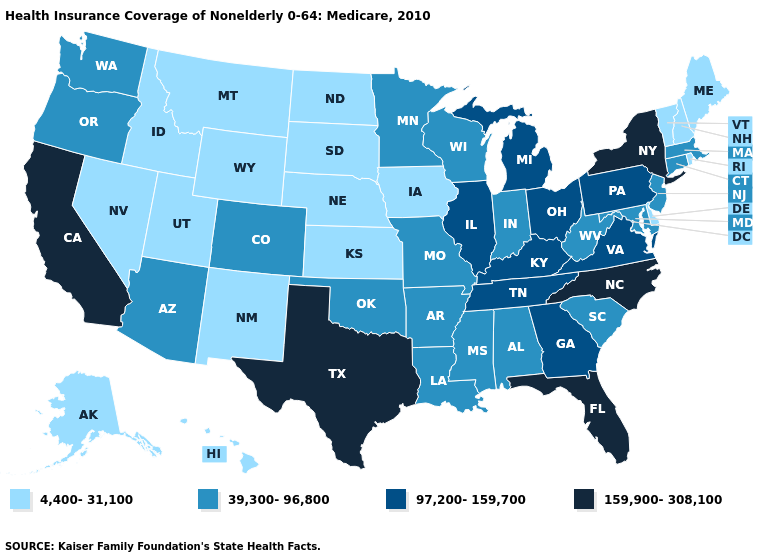Does West Virginia have the lowest value in the USA?
Concise answer only. No. Name the states that have a value in the range 4,400-31,100?
Quick response, please. Alaska, Delaware, Hawaii, Idaho, Iowa, Kansas, Maine, Montana, Nebraska, Nevada, New Hampshire, New Mexico, North Dakota, Rhode Island, South Dakota, Utah, Vermont, Wyoming. What is the lowest value in the West?
Answer briefly. 4,400-31,100. How many symbols are there in the legend?
Be succinct. 4. Name the states that have a value in the range 97,200-159,700?
Short answer required. Georgia, Illinois, Kentucky, Michigan, Ohio, Pennsylvania, Tennessee, Virginia. What is the value of Michigan?
Be succinct. 97,200-159,700. What is the highest value in the West ?
Short answer required. 159,900-308,100. What is the value of Louisiana?
Be succinct. 39,300-96,800. Which states hav the highest value in the West?
Concise answer only. California. What is the lowest value in states that border Nebraska?
Quick response, please. 4,400-31,100. What is the value of South Carolina?
Quick response, please. 39,300-96,800. Does Delaware have the lowest value in the South?
Be succinct. Yes. Does Florida have the highest value in the USA?
Keep it brief. Yes. How many symbols are there in the legend?
Quick response, please. 4. Which states have the lowest value in the West?
Short answer required. Alaska, Hawaii, Idaho, Montana, Nevada, New Mexico, Utah, Wyoming. 